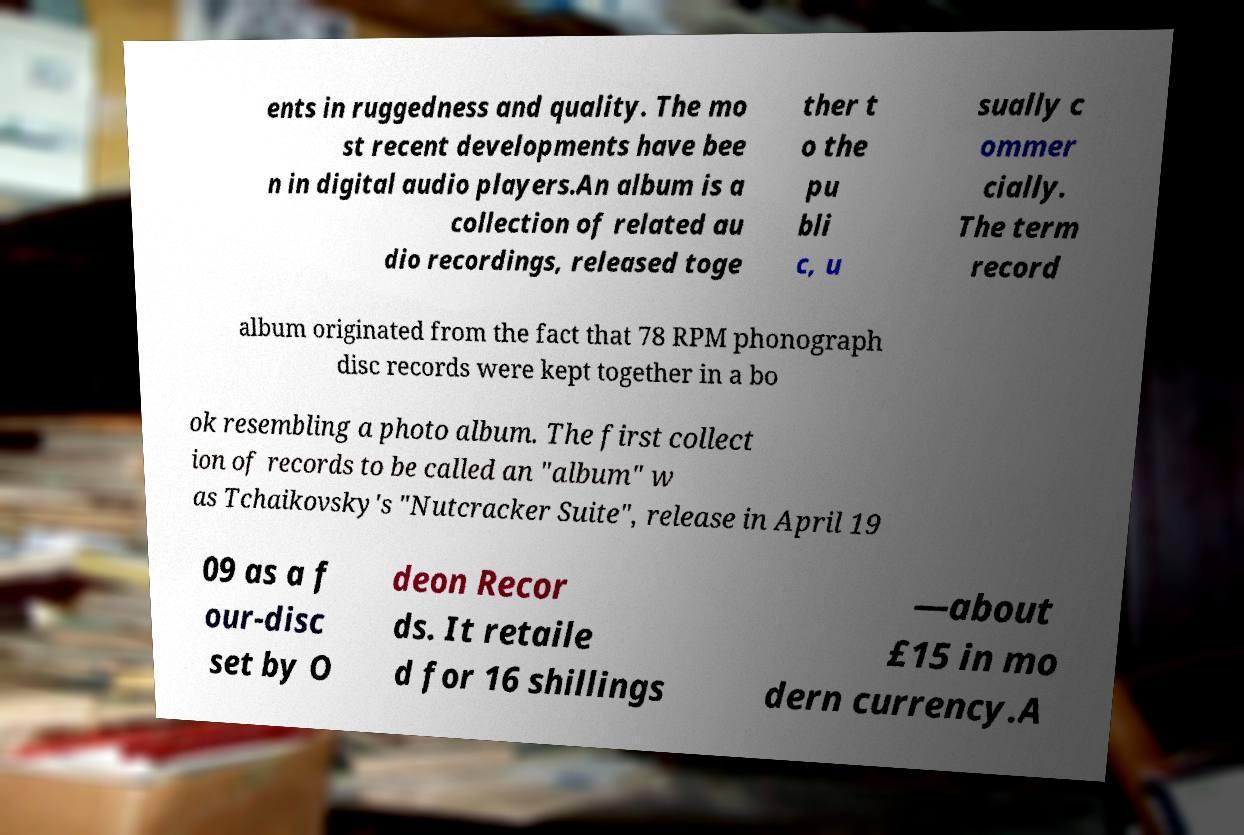Please identify and transcribe the text found in this image. ents in ruggedness and quality. The mo st recent developments have bee n in digital audio players.An album is a collection of related au dio recordings, released toge ther t o the pu bli c, u sually c ommer cially. The term record album originated from the fact that 78 RPM phonograph disc records were kept together in a bo ok resembling a photo album. The first collect ion of records to be called an "album" w as Tchaikovsky's "Nutcracker Suite", release in April 19 09 as a f our-disc set by O deon Recor ds. It retaile d for 16 shillings —about £15 in mo dern currency.A 